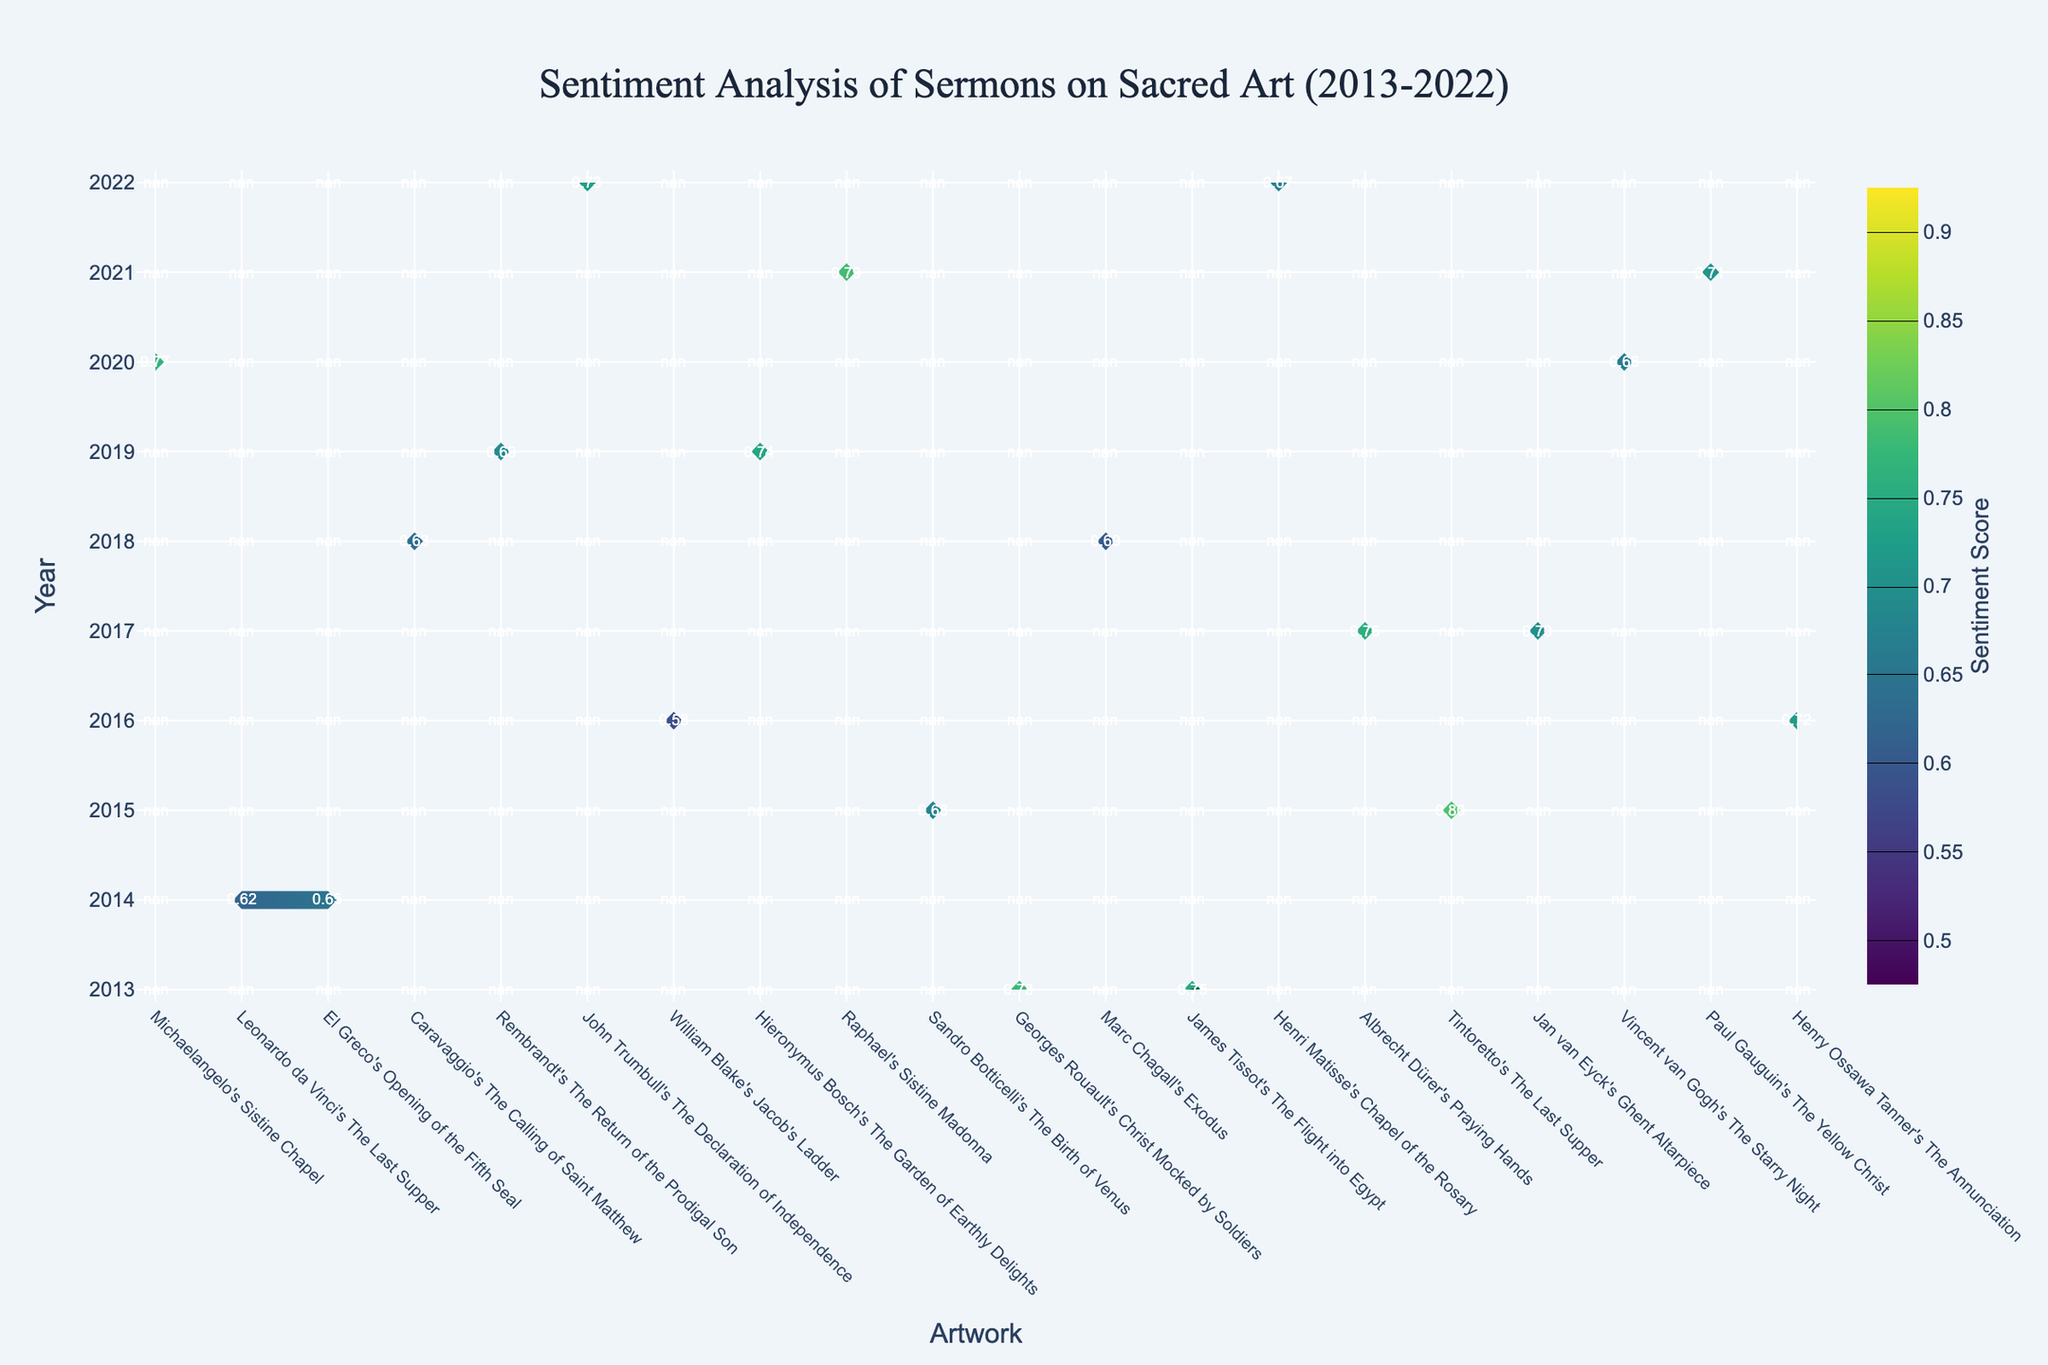What is the title of the plot? The title of the plot is prominently displayed at the top center of the figure.
Answer: Sentiment Analysis of Sermons on Sacred Art (2013-2022) Which year has the highest sentiment score for any topic? By examining the contour plot, the highest sentiment score is around 0.80. Observing the y-axis label and its corresponding data points shows that the highest sentiment score occurs in 2015 for Rembrandt's "The Return of the Prodigal Son."
Answer: 2015 Which artwork has the lowest sentiment score, and in which year did it occur? Identify the lowest value in the contour plot, noting its x-axis and y-axis coordinates. The lowest sentiment score is in 2016 for Hieronymus Bosch's "The Garden of Earthly Delights," with a score of 0.58.
Answer: The Garden of Earthly Delights (2016) What is the average sentiment score for sermons in the year 2020? Locate the year 2020 on the y-axis and note the sentiment scores for Albrecht Dürer's "Praying Hands" (0.77) and Tintoretto's "The Last Supper" (0.66). Calculate the average: (0.77 + 0.66) / 2.
Answer: 0.715 Compare the sentiment scores for the artworks in the years 2013 and 2020. Which year has a higher overall sentiment? Sum the sentiment scores for 2013’s topics and then for 2020’s topics. For 2013: (0.75 for Michaelangelo's "Sistine Chapel” + 0.78 for Leonardo da Vinci's "The Last Supper") = 1.53. For 2020: (0.77 for Albrecht Dürer's "Praying Hands" + 0.66 for Tintoretto's "The Last Supper") = 1.43. 2013 has a higher overall sentiment score.
Answer: 2013 How did the sentiment score for sermons on "The Last Supper" evolve from 2013 to 2020? Check the contour plot for the sentiment score of "The Last Supper" in 2013 and 2020. In 2013, Leonardo da Vinci's "The Last Supper" has a sentiment score of 0.78. In 2020, Tintoretto's "The Last Supper" has a sentiment score of 0.66. This shows a decrease over time.
Answer: Decreased Which artwork maintained a steady sentiment score over different years, and what were those scores? Check the artworks that appear in multiple years and compare their sentiment scores. Leonardo da Vinci’s "The Last Supper" appears in 2013 and Tintoretto's version appears in 2020 with different scores, excluding these due to variance. No artwork maintains the exact same scores year after year; however, the overall trend is noticeable. Specific recurrent artworks have slight changes but aren't identical.
Answer: No artwork What is the range of sentiment scores represented in the plot? Identify the smallest and largest sentiment scores in the contour plot. The contour lines range from 0.5 to 0.9, representing the lowest and highest sentiment scores.
Answer: 0.5 to 0.9 